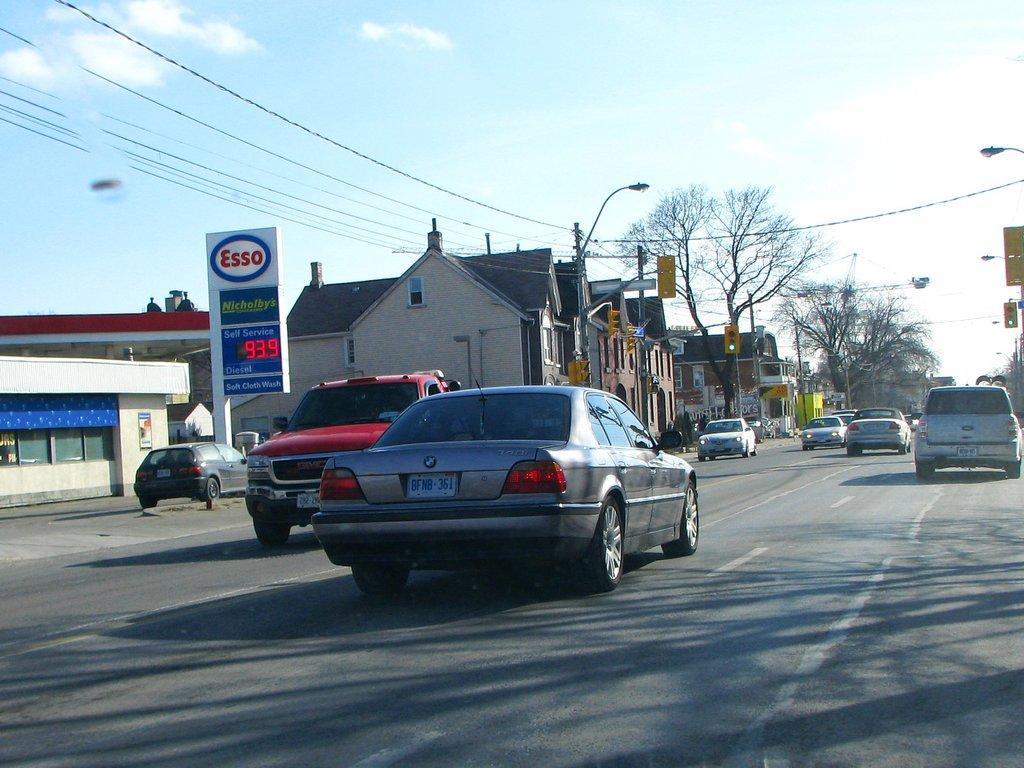Could you give a brief overview of what you see in this image? In this picture I can see the road in front, on which there are number of cars and in the middle of this picture I can see the buildings, few light poles, traffic signals, wires, number of trees and I can see a board on the left side of this image and I see something is written on it. In the background I can see the sky which is clear. 